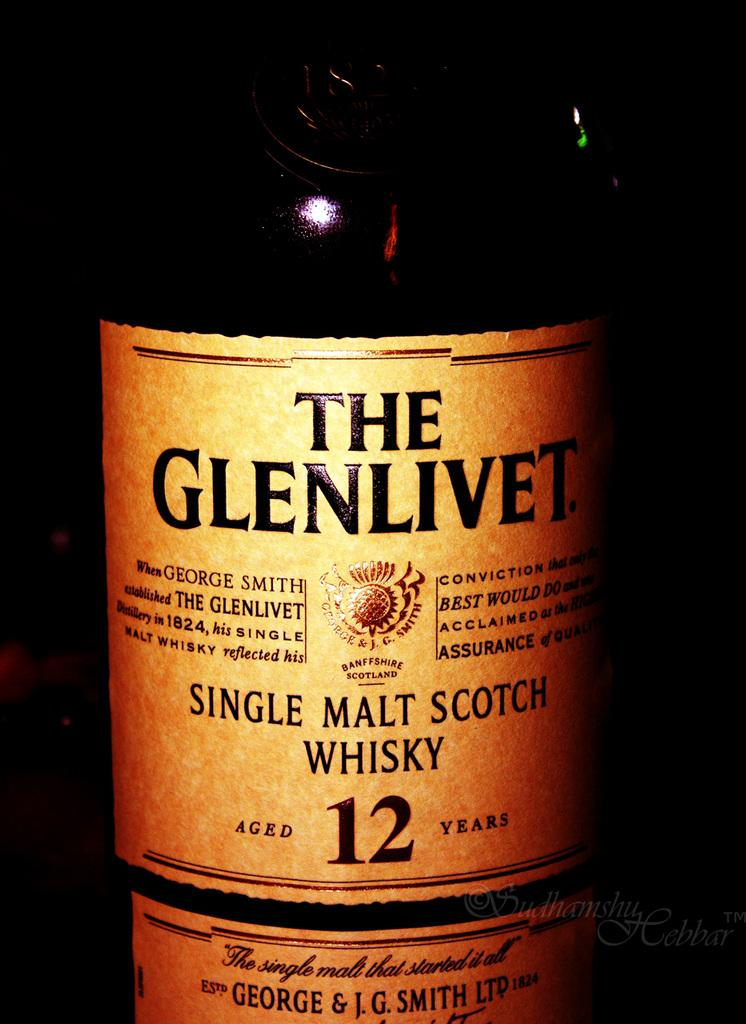<image>
Share a concise interpretation of the image provided. The bottom half of a Glenlivet single malt scotch whiskey bottle showing it has been aged for 12 years 